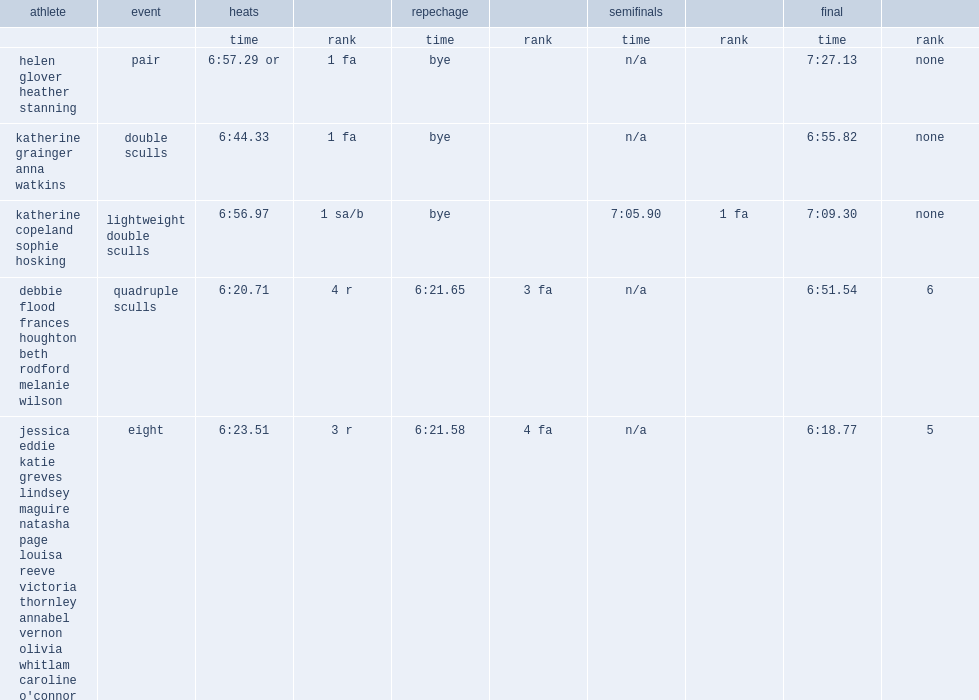What was the result that helen glover and heather stanning got in the heats of the pair? 6:57.29 or. 